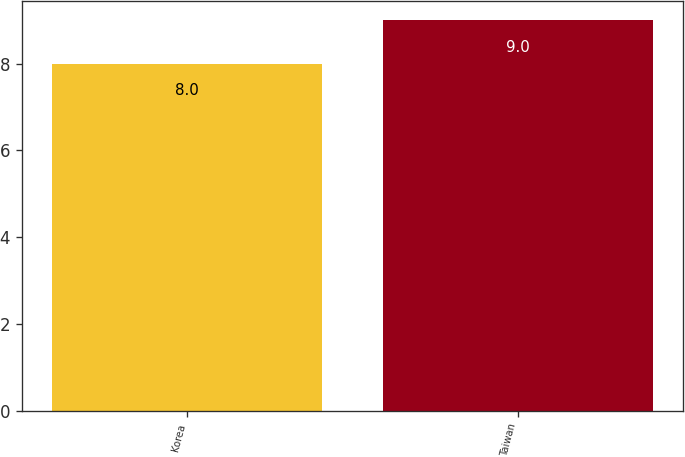Convert chart. <chart><loc_0><loc_0><loc_500><loc_500><bar_chart><fcel>Korea<fcel>Taiwan<nl><fcel>8<fcel>9<nl></chart> 